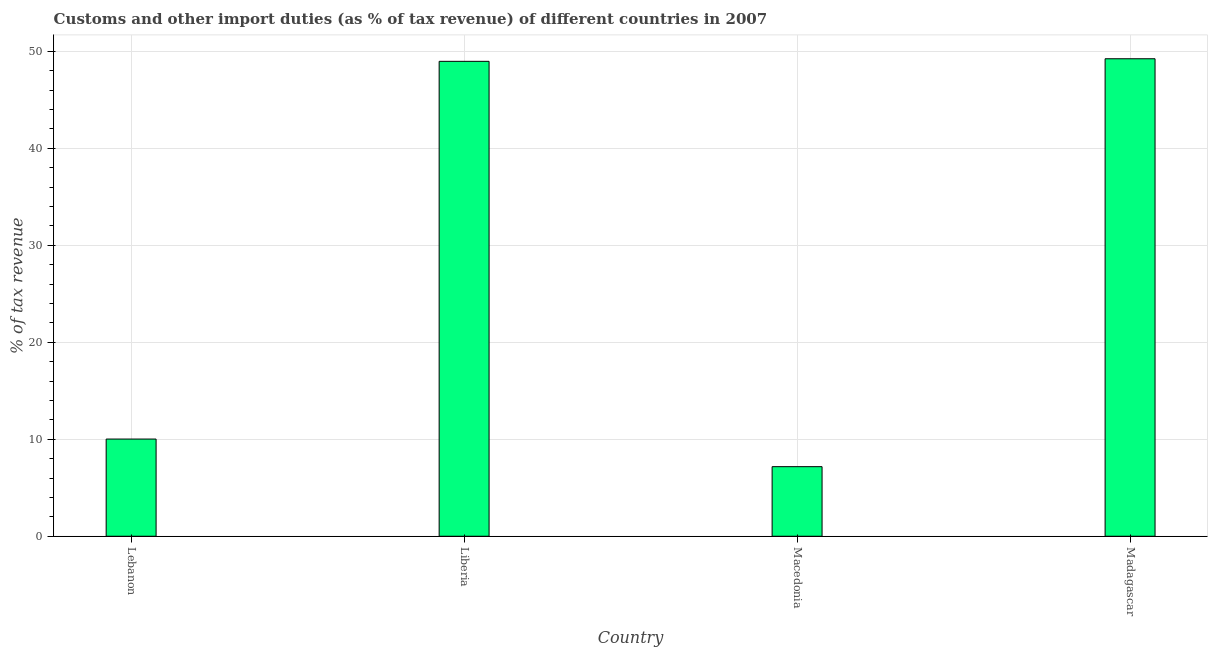Does the graph contain any zero values?
Keep it short and to the point. No. What is the title of the graph?
Offer a very short reply. Customs and other import duties (as % of tax revenue) of different countries in 2007. What is the label or title of the Y-axis?
Ensure brevity in your answer.  % of tax revenue. What is the customs and other import duties in Lebanon?
Offer a terse response. 10.02. Across all countries, what is the maximum customs and other import duties?
Make the answer very short. 49.23. Across all countries, what is the minimum customs and other import duties?
Your answer should be compact. 7.17. In which country was the customs and other import duties maximum?
Offer a very short reply. Madagascar. In which country was the customs and other import duties minimum?
Your response must be concise. Macedonia. What is the sum of the customs and other import duties?
Ensure brevity in your answer.  115.39. What is the difference between the customs and other import duties in Liberia and Madagascar?
Your answer should be compact. -0.27. What is the average customs and other import duties per country?
Make the answer very short. 28.85. What is the median customs and other import duties?
Provide a short and direct response. 29.49. In how many countries, is the customs and other import duties greater than 6 %?
Keep it short and to the point. 4. What is the ratio of the customs and other import duties in Lebanon to that in Macedonia?
Ensure brevity in your answer.  1.4. Is the customs and other import duties in Macedonia less than that in Madagascar?
Keep it short and to the point. Yes. Is the difference between the customs and other import duties in Liberia and Madagascar greater than the difference between any two countries?
Ensure brevity in your answer.  No. What is the difference between the highest and the second highest customs and other import duties?
Provide a succinct answer. 0.27. What is the difference between the highest and the lowest customs and other import duties?
Your response must be concise. 42.06. How many bars are there?
Ensure brevity in your answer.  4. How many countries are there in the graph?
Your response must be concise. 4. What is the % of tax revenue in Lebanon?
Your response must be concise. 10.02. What is the % of tax revenue of Liberia?
Keep it short and to the point. 48.96. What is the % of tax revenue of Macedonia?
Keep it short and to the point. 7.17. What is the % of tax revenue in Madagascar?
Ensure brevity in your answer.  49.23. What is the difference between the % of tax revenue in Lebanon and Liberia?
Your answer should be very brief. -38.94. What is the difference between the % of tax revenue in Lebanon and Macedonia?
Ensure brevity in your answer.  2.85. What is the difference between the % of tax revenue in Lebanon and Madagascar?
Provide a short and direct response. -39.21. What is the difference between the % of tax revenue in Liberia and Macedonia?
Provide a short and direct response. 41.79. What is the difference between the % of tax revenue in Liberia and Madagascar?
Provide a short and direct response. -0.27. What is the difference between the % of tax revenue in Macedonia and Madagascar?
Ensure brevity in your answer.  -42.06. What is the ratio of the % of tax revenue in Lebanon to that in Liberia?
Make the answer very short. 0.2. What is the ratio of the % of tax revenue in Lebanon to that in Macedonia?
Make the answer very short. 1.4. What is the ratio of the % of tax revenue in Lebanon to that in Madagascar?
Provide a succinct answer. 0.2. What is the ratio of the % of tax revenue in Liberia to that in Macedonia?
Your answer should be compact. 6.82. What is the ratio of the % of tax revenue in Liberia to that in Madagascar?
Ensure brevity in your answer.  0.99. What is the ratio of the % of tax revenue in Macedonia to that in Madagascar?
Your answer should be compact. 0.15. 